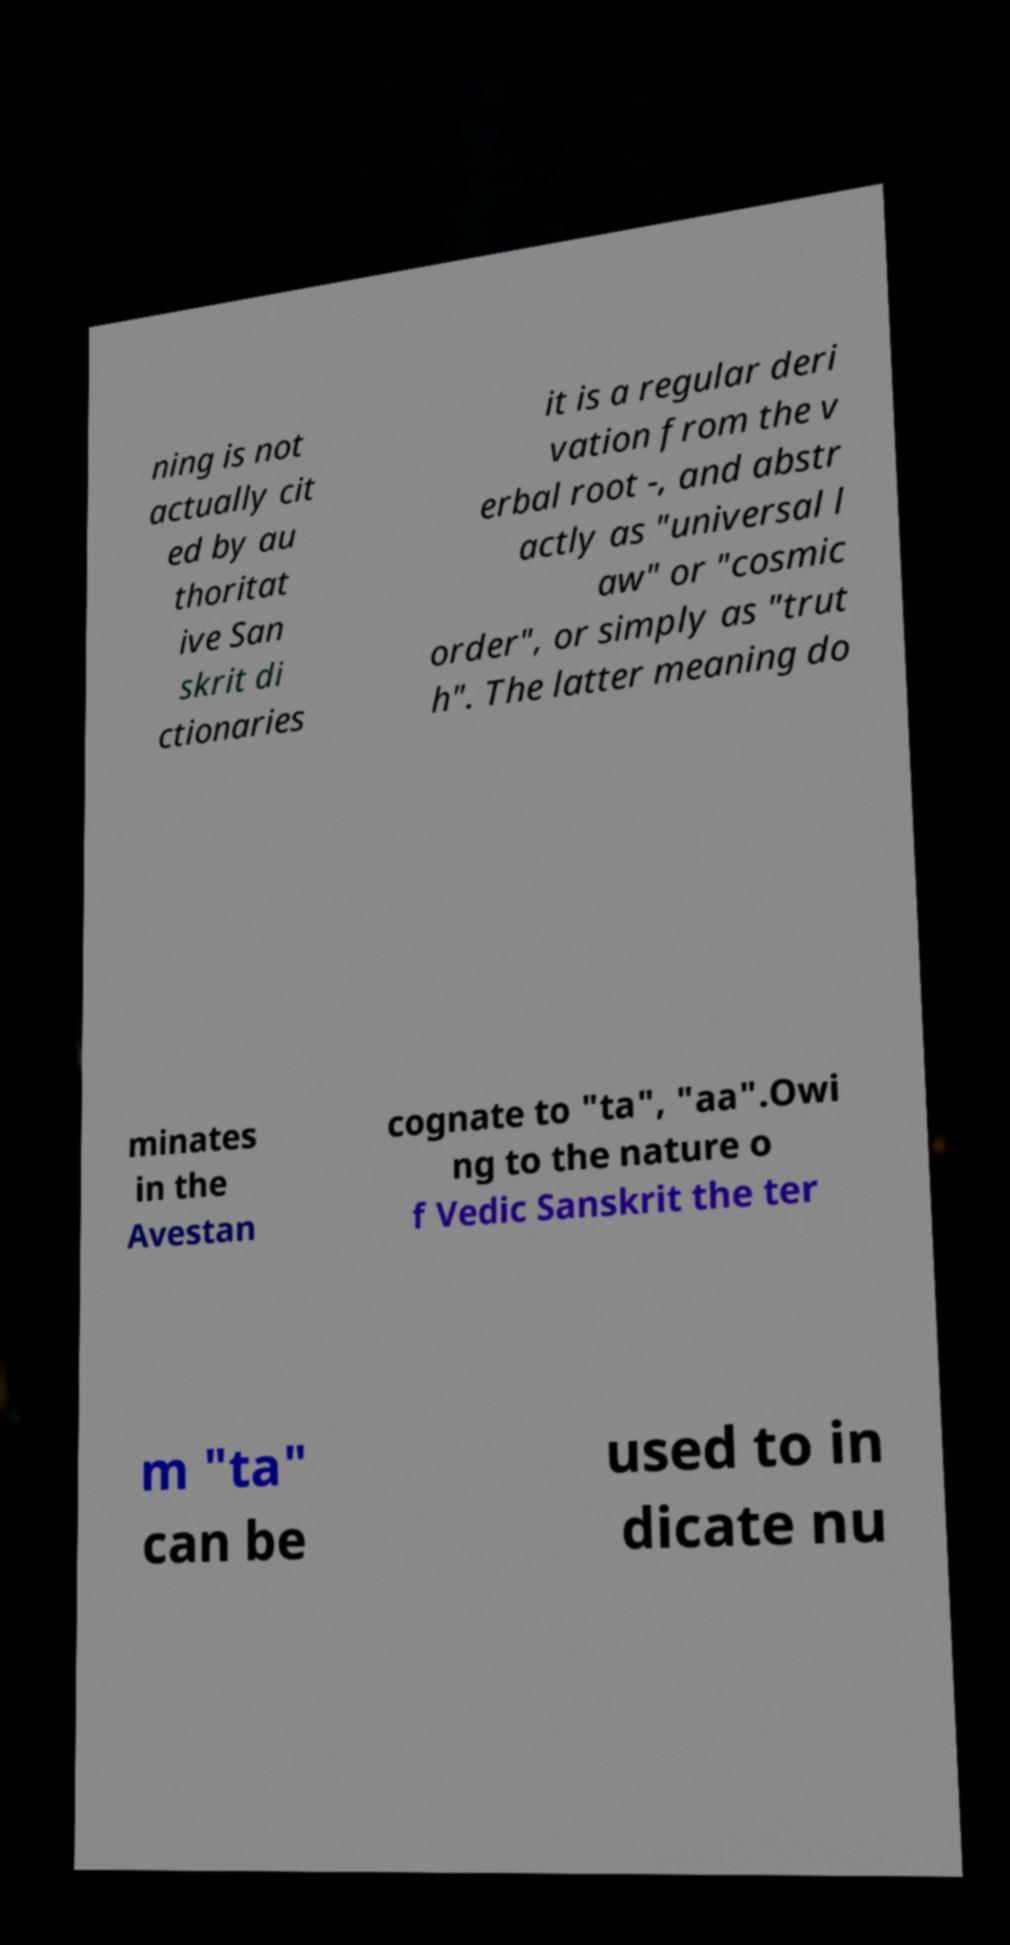What messages or text are displayed in this image? I need them in a readable, typed format. ning is not actually cit ed by au thoritat ive San skrit di ctionaries it is a regular deri vation from the v erbal root -, and abstr actly as "universal l aw" or "cosmic order", or simply as "trut h". The latter meaning do minates in the Avestan cognate to "ta", "aa".Owi ng to the nature o f Vedic Sanskrit the ter m "ta" can be used to in dicate nu 